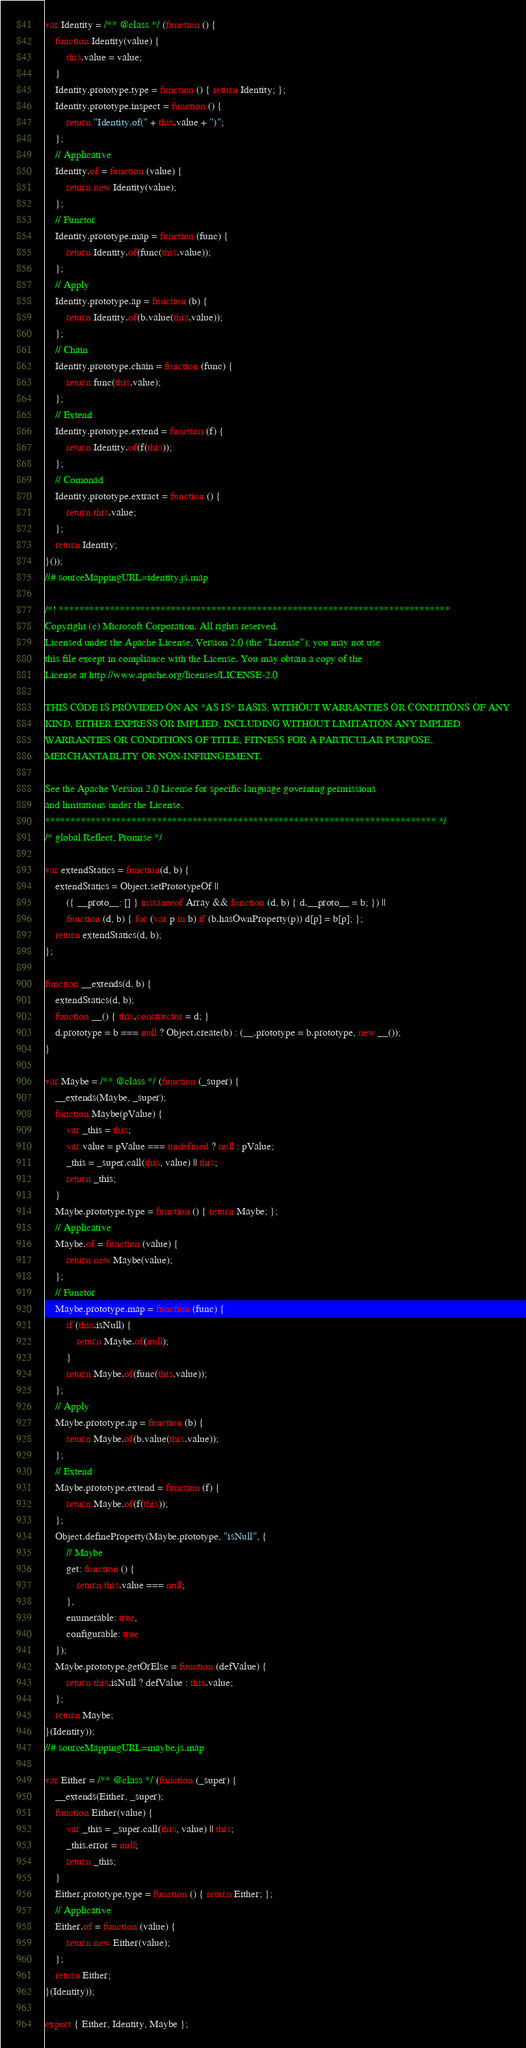<code> <loc_0><loc_0><loc_500><loc_500><_JavaScript_>var Identity = /** @class */ (function () {
    function Identity(value) {
        this.value = value;
    }
    Identity.prototype.type = function () { return Identity; };
    Identity.prototype.inspect = function () {
        return "Identity.of(" + this.value + ")";
    };
    // Applicative
    Identity.of = function (value) {
        return new Identity(value);
    };
    // Functor
    Identity.prototype.map = function (func) {
        return Identity.of(func(this.value));
    };
    // Apply
    Identity.prototype.ap = function (b) {
        return Identity.of(b.value(this.value));
    };
    // Chain
    Identity.prototype.chain = function (func) {
        return func(this.value);
    };
    // Extend
    Identity.prototype.extend = function (f) {
        return Identity.of(f(this));
    };
    // Comonad
    Identity.prototype.extract = function () {
        return this.value;
    };
    return Identity;
}());
//# sourceMappingURL=identity.js.map

/*! *****************************************************************************
Copyright (c) Microsoft Corporation. All rights reserved.
Licensed under the Apache License, Version 2.0 (the "License"); you may not use
this file except in compliance with the License. You may obtain a copy of the
License at http://www.apache.org/licenses/LICENSE-2.0

THIS CODE IS PROVIDED ON AN *AS IS* BASIS, WITHOUT WARRANTIES OR CONDITIONS OF ANY
KIND, EITHER EXPRESS OR IMPLIED, INCLUDING WITHOUT LIMITATION ANY IMPLIED
WARRANTIES OR CONDITIONS OF TITLE, FITNESS FOR A PARTICULAR PURPOSE,
MERCHANTABLITY OR NON-INFRINGEMENT.

See the Apache Version 2.0 License for specific language governing permissions
and limitations under the License.
***************************************************************************** */
/* global Reflect, Promise */

var extendStatics = function(d, b) {
    extendStatics = Object.setPrototypeOf ||
        ({ __proto__: [] } instanceof Array && function (d, b) { d.__proto__ = b; }) ||
        function (d, b) { for (var p in b) if (b.hasOwnProperty(p)) d[p] = b[p]; };
    return extendStatics(d, b);
};

function __extends(d, b) {
    extendStatics(d, b);
    function __() { this.constructor = d; }
    d.prototype = b === null ? Object.create(b) : (__.prototype = b.prototype, new __());
}

var Maybe = /** @class */ (function (_super) {
    __extends(Maybe, _super);
    function Maybe(pValue) {
        var _this = this;
        var value = pValue === undefined ? null : pValue;
        _this = _super.call(this, value) || this;
        return _this;
    }
    Maybe.prototype.type = function () { return Maybe; };
    // Applicative
    Maybe.of = function (value) {
        return new Maybe(value);
    };
    // Functor
    Maybe.prototype.map = function (func) {
        if (this.isNull) {
            return Maybe.of(null);
        }
        return Maybe.of(func(this.value));
    };
    // Apply
    Maybe.prototype.ap = function (b) {
        return Maybe.of(b.value(this.value));
    };
    // Extend
    Maybe.prototype.extend = function (f) {
        return Maybe.of(f(this));
    };
    Object.defineProperty(Maybe.prototype, "isNull", {
        // Maybe
        get: function () {
            return this.value === null;
        },
        enumerable: true,
        configurable: true
    });
    Maybe.prototype.getOrElse = function (defValue) {
        return this.isNull ? defValue : this.value;
    };
    return Maybe;
}(Identity));
//# sourceMappingURL=maybe.js.map

var Either = /** @class */ (function (_super) {
    __extends(Either, _super);
    function Either(value) {
        var _this = _super.call(this, value) || this;
        _this.error = null;
        return _this;
    }
    Either.prototype.type = function () { return Either; };
    // Applicative
    Either.of = function (value) {
        return new Either(value);
    };
    return Either;
}(Identity));

export { Either, Identity, Maybe };
</code> 